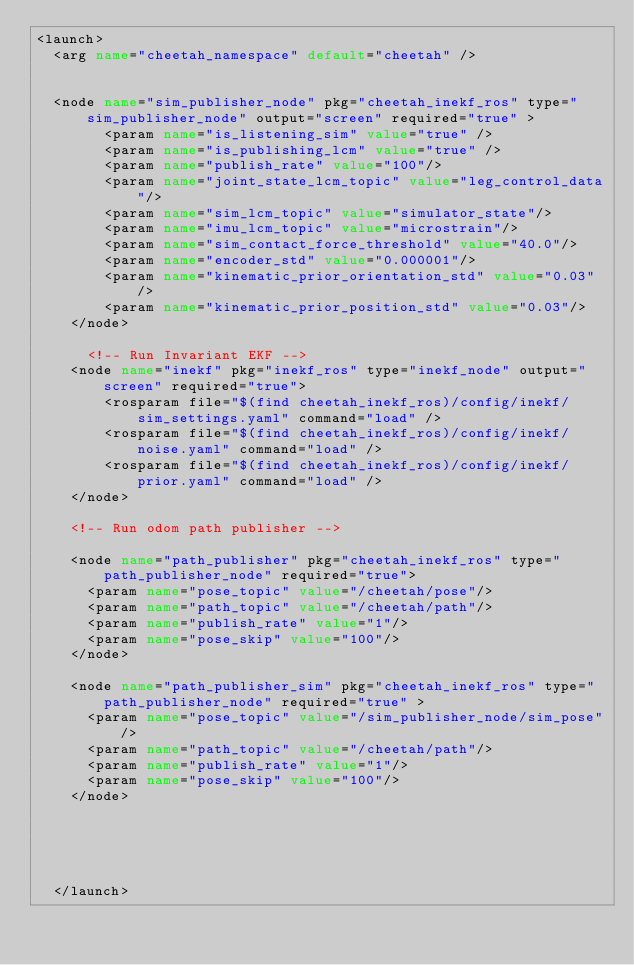<code> <loc_0><loc_0><loc_500><loc_500><_XML_><launch>
  <arg name="cheetah_namespace" default="cheetah" />


  <node name="sim_publisher_node" pkg="cheetah_inekf_ros" type="sim_publisher_node" output="screen" required="true" >
        <param name="is_listening_sim" value="true" />
        <param name="is_publishing_lcm" value="true" />
        <param name="publish_rate" value="100"/>
        <param name="joint_state_lcm_topic" value="leg_control_data"/>
        <param name="sim_lcm_topic" value="simulator_state"/>
        <param name="imu_lcm_topic" value="microstrain"/>
        <param name="sim_contact_force_threshold" value="40.0"/>
        <param name="encoder_std" value="0.000001"/>
        <param name="kinematic_prior_orientation_std" value="0.03"/>
        <param name="kinematic_prior_position_std" value="0.03"/>
    </node>

      <!-- Run Invariant EKF -->
    <node name="inekf" pkg="inekf_ros" type="inekf_node" output="screen" required="true">
        <rosparam file="$(find cheetah_inekf_ros)/config/inekf/sim_settings.yaml" command="load" />
        <rosparam file="$(find cheetah_inekf_ros)/config/inekf/noise.yaml" command="load" />
        <rosparam file="$(find cheetah_inekf_ros)/config/inekf/prior.yaml" command="load" />
    </node> 

    <!-- Run odom path publisher -->

    <node name="path_publisher" pkg="cheetah_inekf_ros" type="path_publisher_node" required="true">
      <param name="pose_topic" value="/cheetah/pose"/>
      <param name="path_topic" value="/cheetah/path"/>
      <param name="publish_rate" value="1"/>
      <param name="pose_skip" value="100"/>
    </node>

    <node name="path_publisher_sim" pkg="cheetah_inekf_ros" type="path_publisher_node" required="true" >
      <param name="pose_topic" value="/sim_publisher_node/sim_pose"/>
      <param name="path_topic" value="/cheetah/path"/>
      <param name="publish_rate" value="1"/>
      <param name="pose_skip" value="100"/>
    </node>




    
  </launch>
</code> 